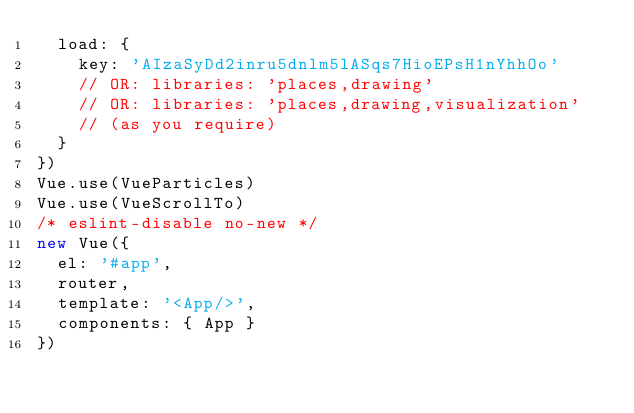<code> <loc_0><loc_0><loc_500><loc_500><_JavaScript_>  load: {
    key: 'AIzaSyDd2inru5dnlm5lASqs7HioEPsH1nYhhOo'
    // OR: libraries: 'places,drawing'
    // OR: libraries: 'places,drawing,visualization'
    // (as you require)
  }
})
Vue.use(VueParticles)
Vue.use(VueScrollTo)
/* eslint-disable no-new */
new Vue({
  el: '#app',
  router,
  template: '<App/>',
  components: { App }
})
</code> 